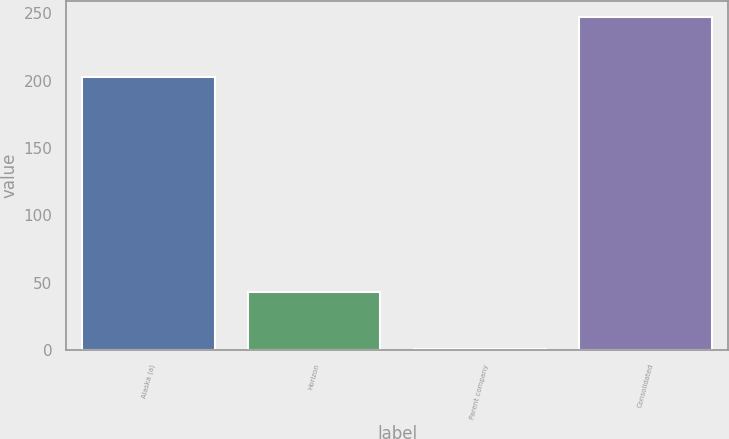Convert chart. <chart><loc_0><loc_0><loc_500><loc_500><bar_chart><fcel>Alaska (a)<fcel>Horizon<fcel>Parent company<fcel>Consolidated<nl><fcel>202.9<fcel>43.4<fcel>0.6<fcel>246.9<nl></chart> 